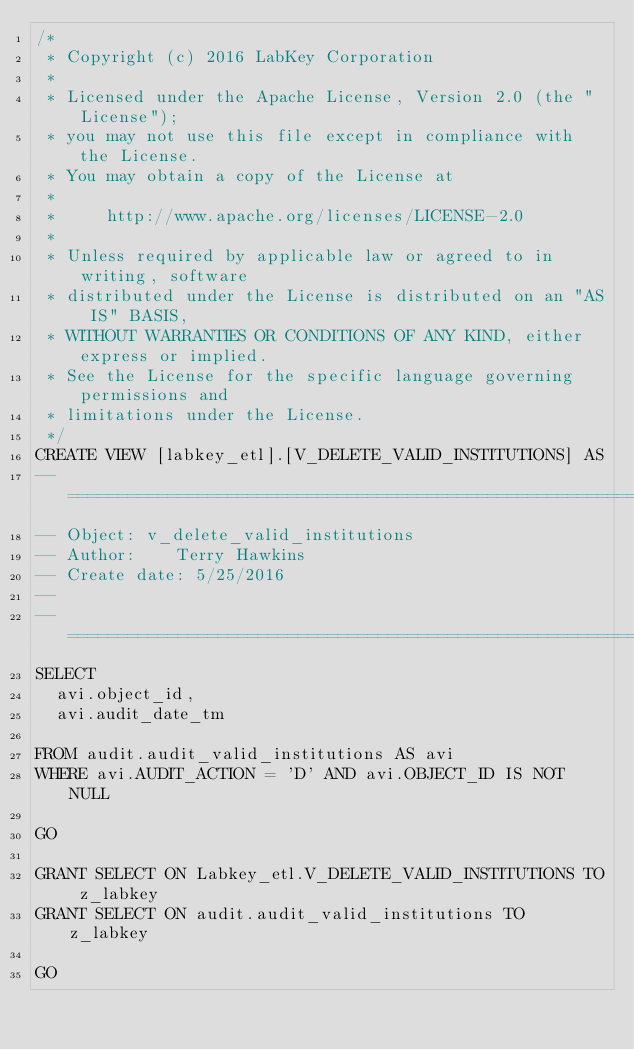Convert code to text. <code><loc_0><loc_0><loc_500><loc_500><_SQL_>/*
 * Copyright (c) 2016 LabKey Corporation
 *
 * Licensed under the Apache License, Version 2.0 (the "License");
 * you may not use this file except in compliance with the License.
 * You may obtain a copy of the License at
 *
 *     http://www.apache.org/licenses/LICENSE-2.0
 *
 * Unless required by applicable law or agreed to in writing, software
 * distributed under the License is distributed on an "AS IS" BASIS,
 * WITHOUT WARRANTIES OR CONDITIONS OF ANY KIND, either express or implied.
 * See the License for the specific language governing permissions and
 * limitations under the License.
 */
CREATE VIEW [labkey_etl].[V_DELETE_VALID_INSTITUTIONS] AS
-- ====================================================================================================================
-- Object: v_delete_valid_institutions
-- Author:		Terry Hawkins
-- Create date: 5/25/2016
--
-- ==========================================================================================
SELECT
	avi.object_id,
	avi.audit_date_tm

FROM audit.audit_valid_institutions AS avi
WHERE avi.AUDIT_ACTION = 'D' AND avi.OBJECT_ID IS NOT NULL

GO

GRANT SELECT ON Labkey_etl.V_DELETE_VALID_INSTITUTIONS TO z_labkey
GRANT SELECT ON audit.audit_valid_institutions TO z_labkey

GO</code> 